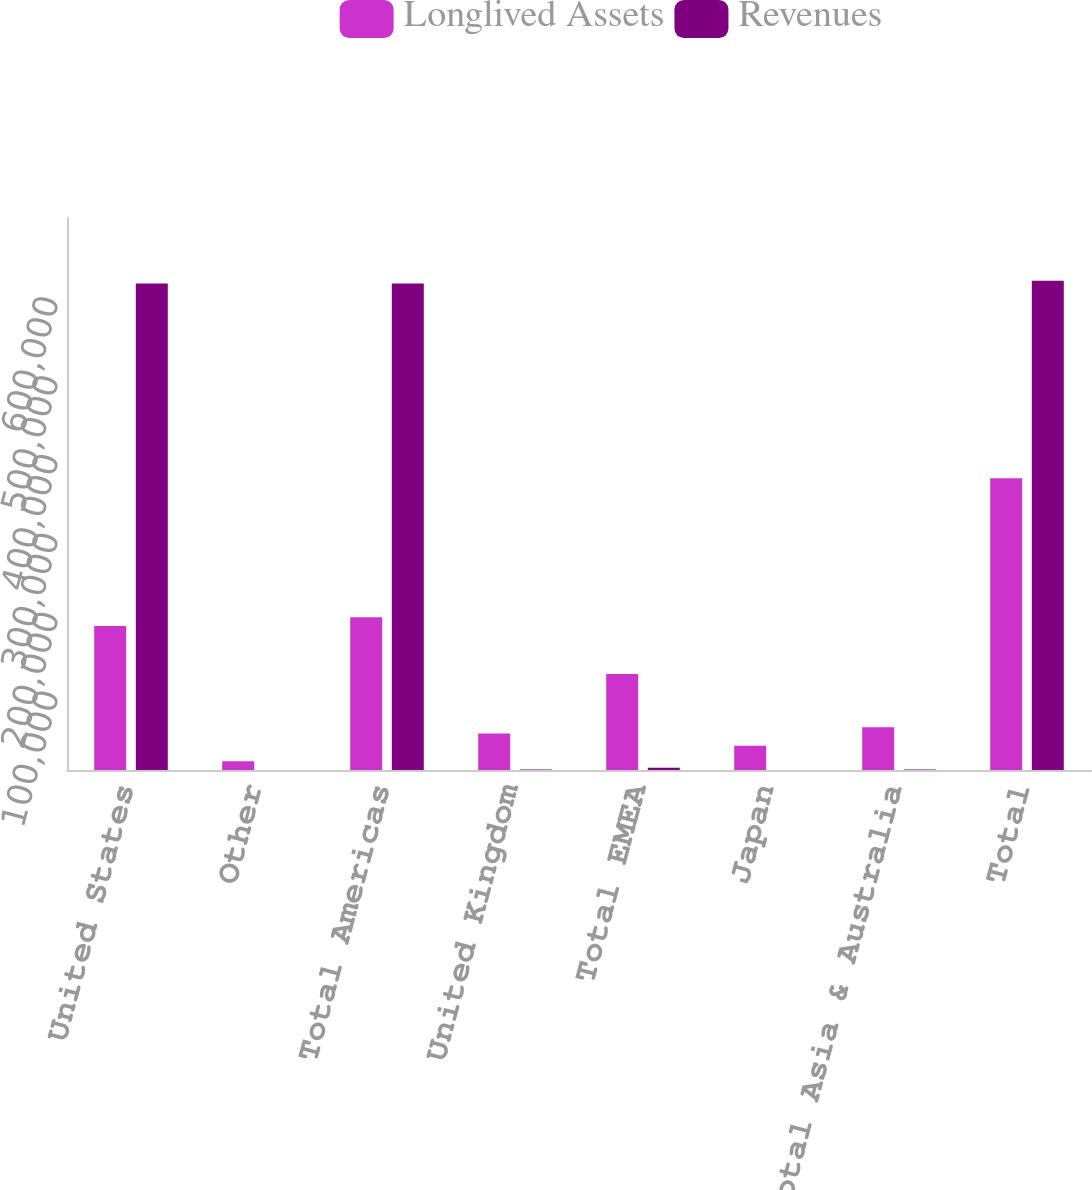Convert chart. <chart><loc_0><loc_0><loc_500><loc_500><stacked_bar_chart><ecel><fcel>United States<fcel>Other<fcel>Total Americas<fcel>United Kingdom<fcel>Total EMEA<fcel>Japan<fcel>Total Asia & Australia<fcel>Total<nl><fcel>Longlived Assets<fcel>182573<fcel>11232<fcel>193805<fcel>46272<fcel>121822<fcel>30902<fcel>54259<fcel>369886<nl><fcel>Revenues<fcel>616856<fcel>2<fcel>616858<fcel>482<fcel>2720<fcel>120<fcel>698<fcel>620276<nl></chart> 